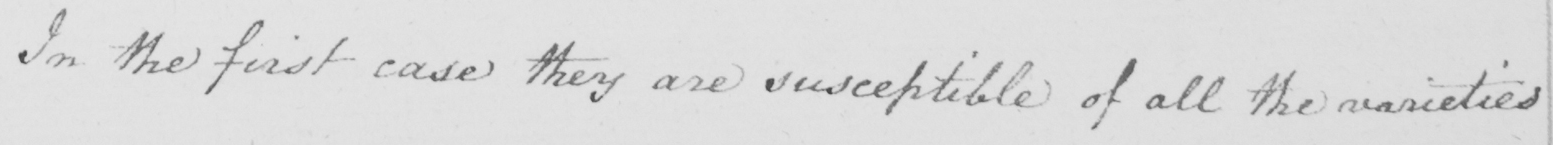Can you tell me what this handwritten text says? In the first case they are susceptible of all the varieties 